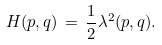<formula> <loc_0><loc_0><loc_500><loc_500>H ( p , q ) \, = \, \frac { 1 } { 2 } \lambda ^ { 2 } ( p , q ) .</formula> 